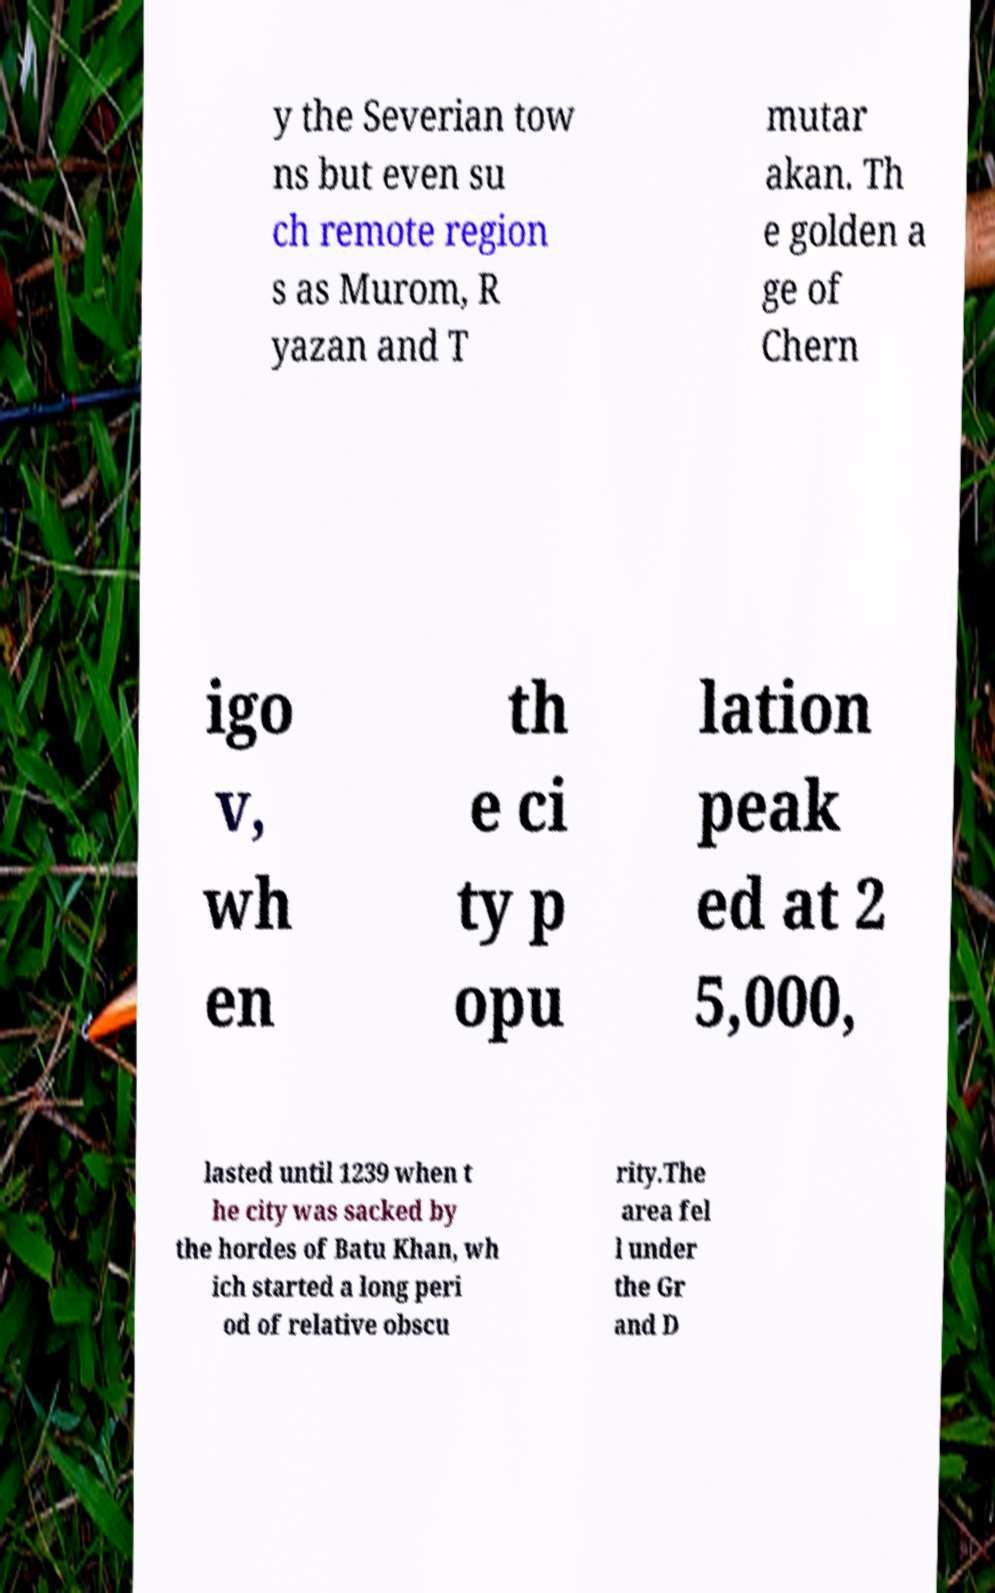Could you assist in decoding the text presented in this image and type it out clearly? y the Severian tow ns but even su ch remote region s as Murom, R yazan and T mutar akan. Th e golden a ge of Chern igo v, wh en th e ci ty p opu lation peak ed at 2 5,000, lasted until 1239 when t he city was sacked by the hordes of Batu Khan, wh ich started a long peri od of relative obscu rity.The area fel l under the Gr and D 